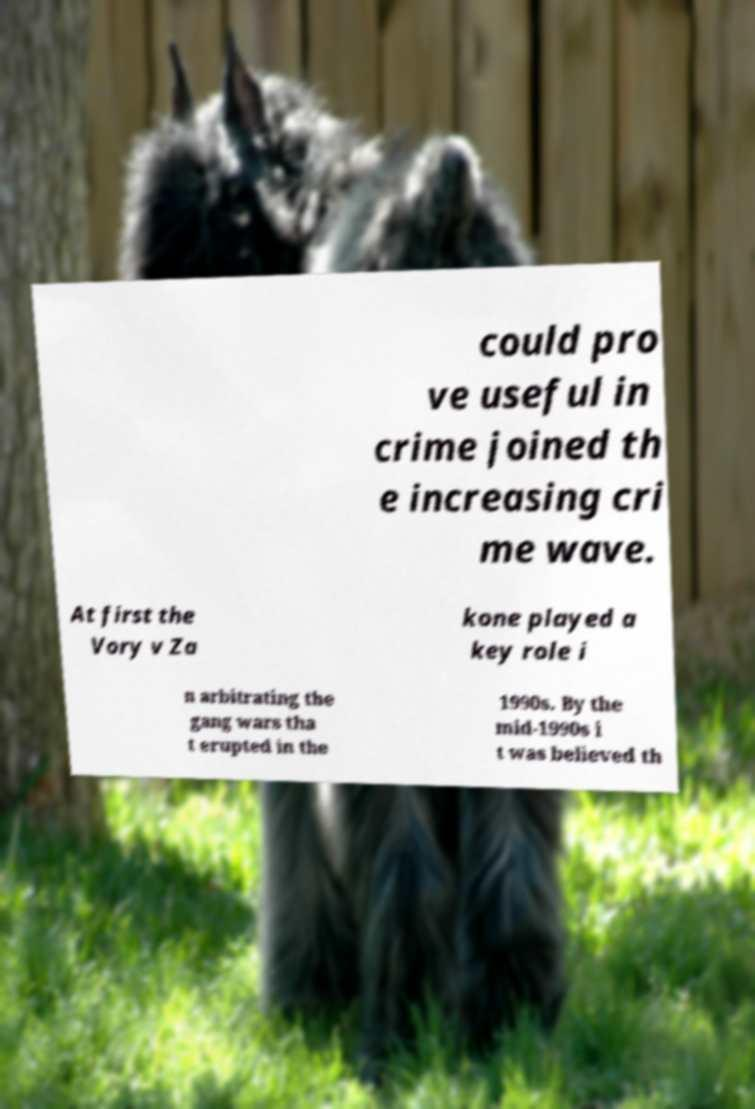Can you accurately transcribe the text from the provided image for me? could pro ve useful in crime joined th e increasing cri me wave. At first the Vory v Za kone played a key role i n arbitrating the gang wars tha t erupted in the 1990s. By the mid-1990s i t was believed th 